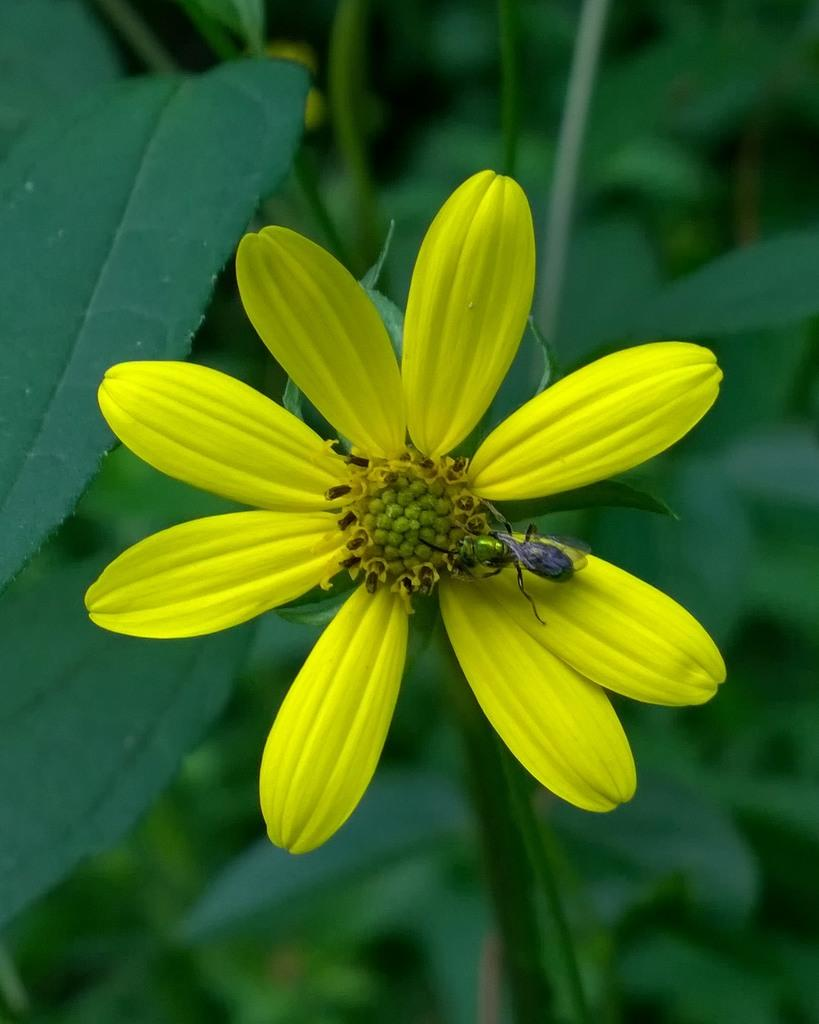What color are the petals of the flower in the image? The petals of the flower in the image are yellow. Is there anything on the flower in the image? Yes, there is an insect on the flower in the image. What else can be seen in the image besides the flower and insect? There are plants under the flower in the image. What type of flag can be seen waving in the background of the image? There is no flag present in the image; it features a flower with yellow petals, an insect, and plants. 